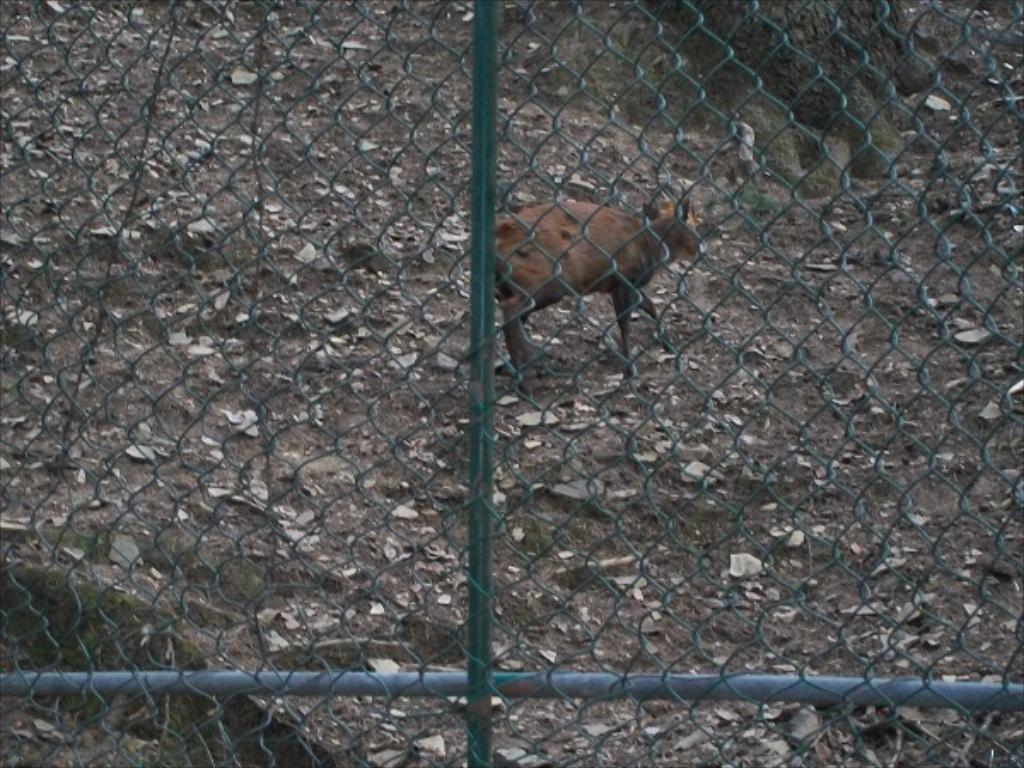What type of creature is present in the image? There is an animal in the image. Can you describe the color of the animal? The animal is brown in color. What is the purpose of the fence in the image? The fence is likely used to enclose or separate areas. What is the iron pole in the image used for? The iron pole may be used as a support or for decoration. What time of day is it in the image, given the presence of children playing nearby? There is no mention of children playing in the image, so we cannot determine the time of day based on that information. 